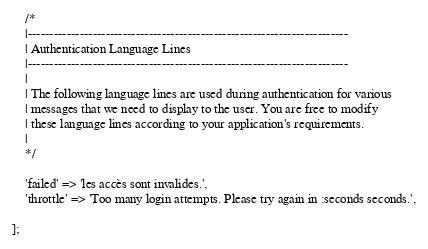<code> <loc_0><loc_0><loc_500><loc_500><_PHP_>
    /*
    |--------------------------------------------------------------------------
    | Authentication Language Lines
    |--------------------------------------------------------------------------
    |
    | The following language lines are used during authentication for various
    | messages that we need to display to the user. You are free to modify
    | these language lines according to your application's requirements.
    |
    */

    'failed' => 'les accès sont invalides.',
    'throttle' => 'Too many login attempts. Please try again in :seconds seconds.',

];
</code> 